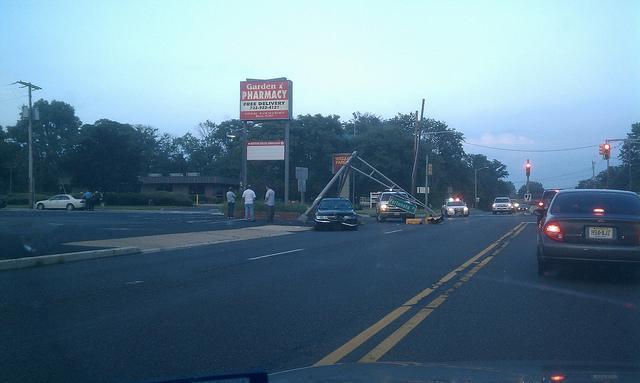How many red vehicles are on the street?
Give a very brief answer. 0. How many police cars are there?
Give a very brief answer. 1. 